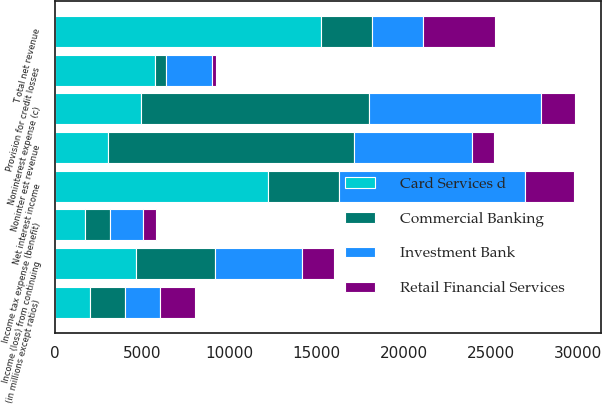Convert chart. <chart><loc_0><loc_0><loc_500><loc_500><stacked_bar_chart><ecel><fcel>(in millions except ratios)<fcel>Noninter est revenue<fcel>Net interest income<fcel>T otal net revenue<fcel>Provision for credit losses<fcel>Noninterest expense (c)<fcel>Income (loss) from continuing<fcel>Income tax expense (benefit)<nl><fcel>Commercial Banking<fcel>2007<fcel>14094<fcel>4076<fcel>2943<fcel>654<fcel>13074<fcel>4563<fcel>1424<nl><fcel>Investment Bank<fcel>2007<fcel>6803<fcel>10676<fcel>2943<fcel>2610<fcel>9900<fcel>4969<fcel>1934<nl><fcel>Card Services d<fcel>2007<fcel>3046<fcel>12189<fcel>15235<fcel>5711<fcel>4914<fcel>4610<fcel>1691<nl><fcel>Retail Financial Services<fcel>2007<fcel>1263<fcel>2840<fcel>4103<fcel>279<fcel>1958<fcel>1866<fcel>732<nl></chart> 